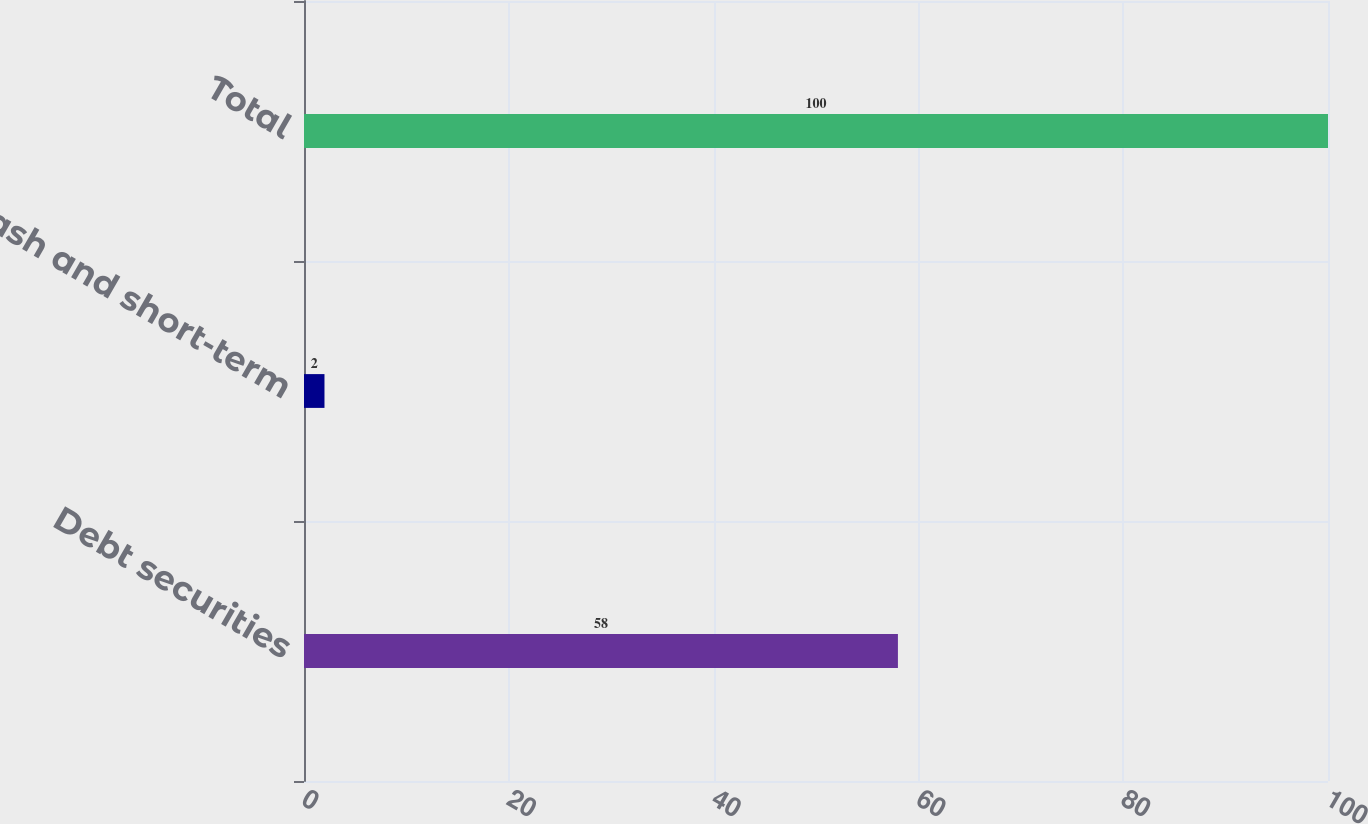Convert chart. <chart><loc_0><loc_0><loc_500><loc_500><bar_chart><fcel>Debt securities<fcel>Cash and short-term<fcel>Total<nl><fcel>58<fcel>2<fcel>100<nl></chart> 